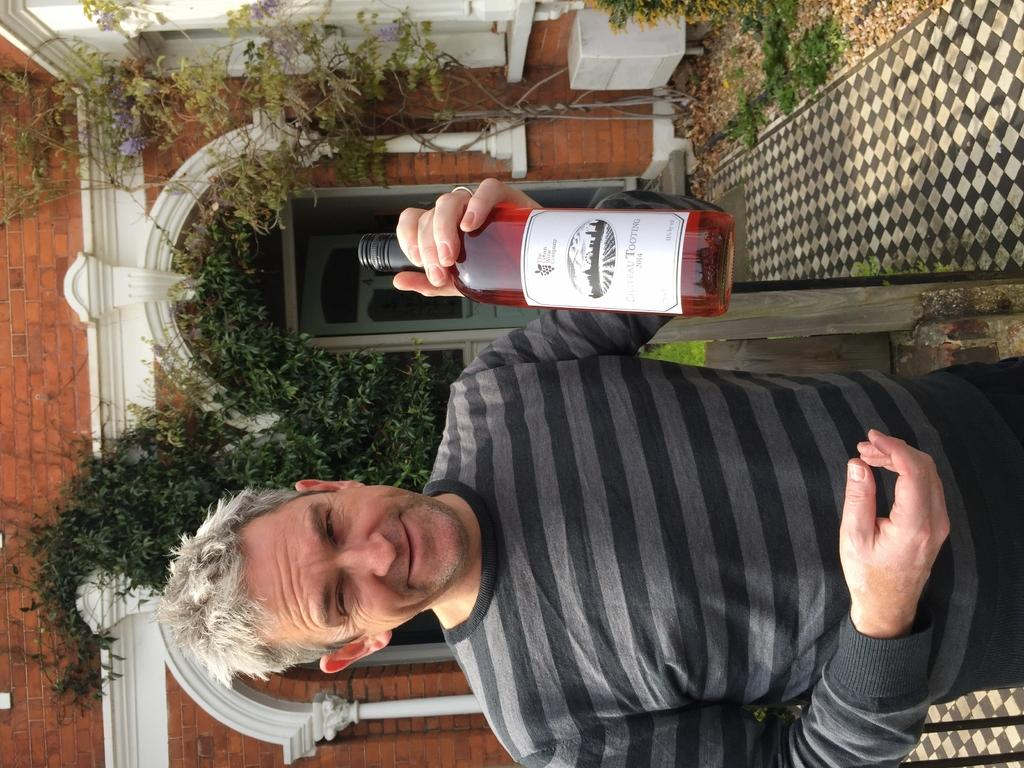Who or what is present in the image? There is a person in the image. What is the person holding? The person is holding a bottle. What can be seen in the distance behind the person? There is a building and trees in the background of the image. How many dimes are visible on the person's clothing in the image? There are no dimes visible on the person's clothing in the image. 